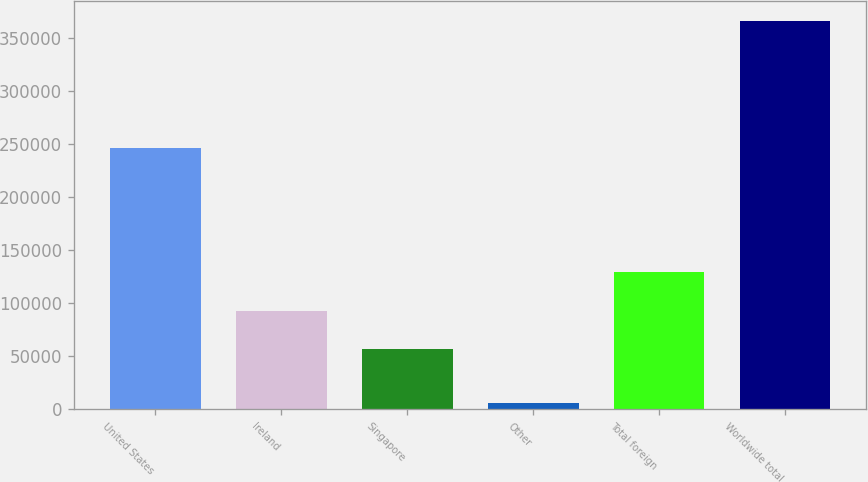<chart> <loc_0><loc_0><loc_500><loc_500><bar_chart><fcel>United States<fcel>Ireland<fcel>Singapore<fcel>Other<fcel>Total foreign<fcel>Worldwide total<nl><fcel>245698<fcel>92862.6<fcel>56869<fcel>5942<fcel>128856<fcel>365878<nl></chart> 